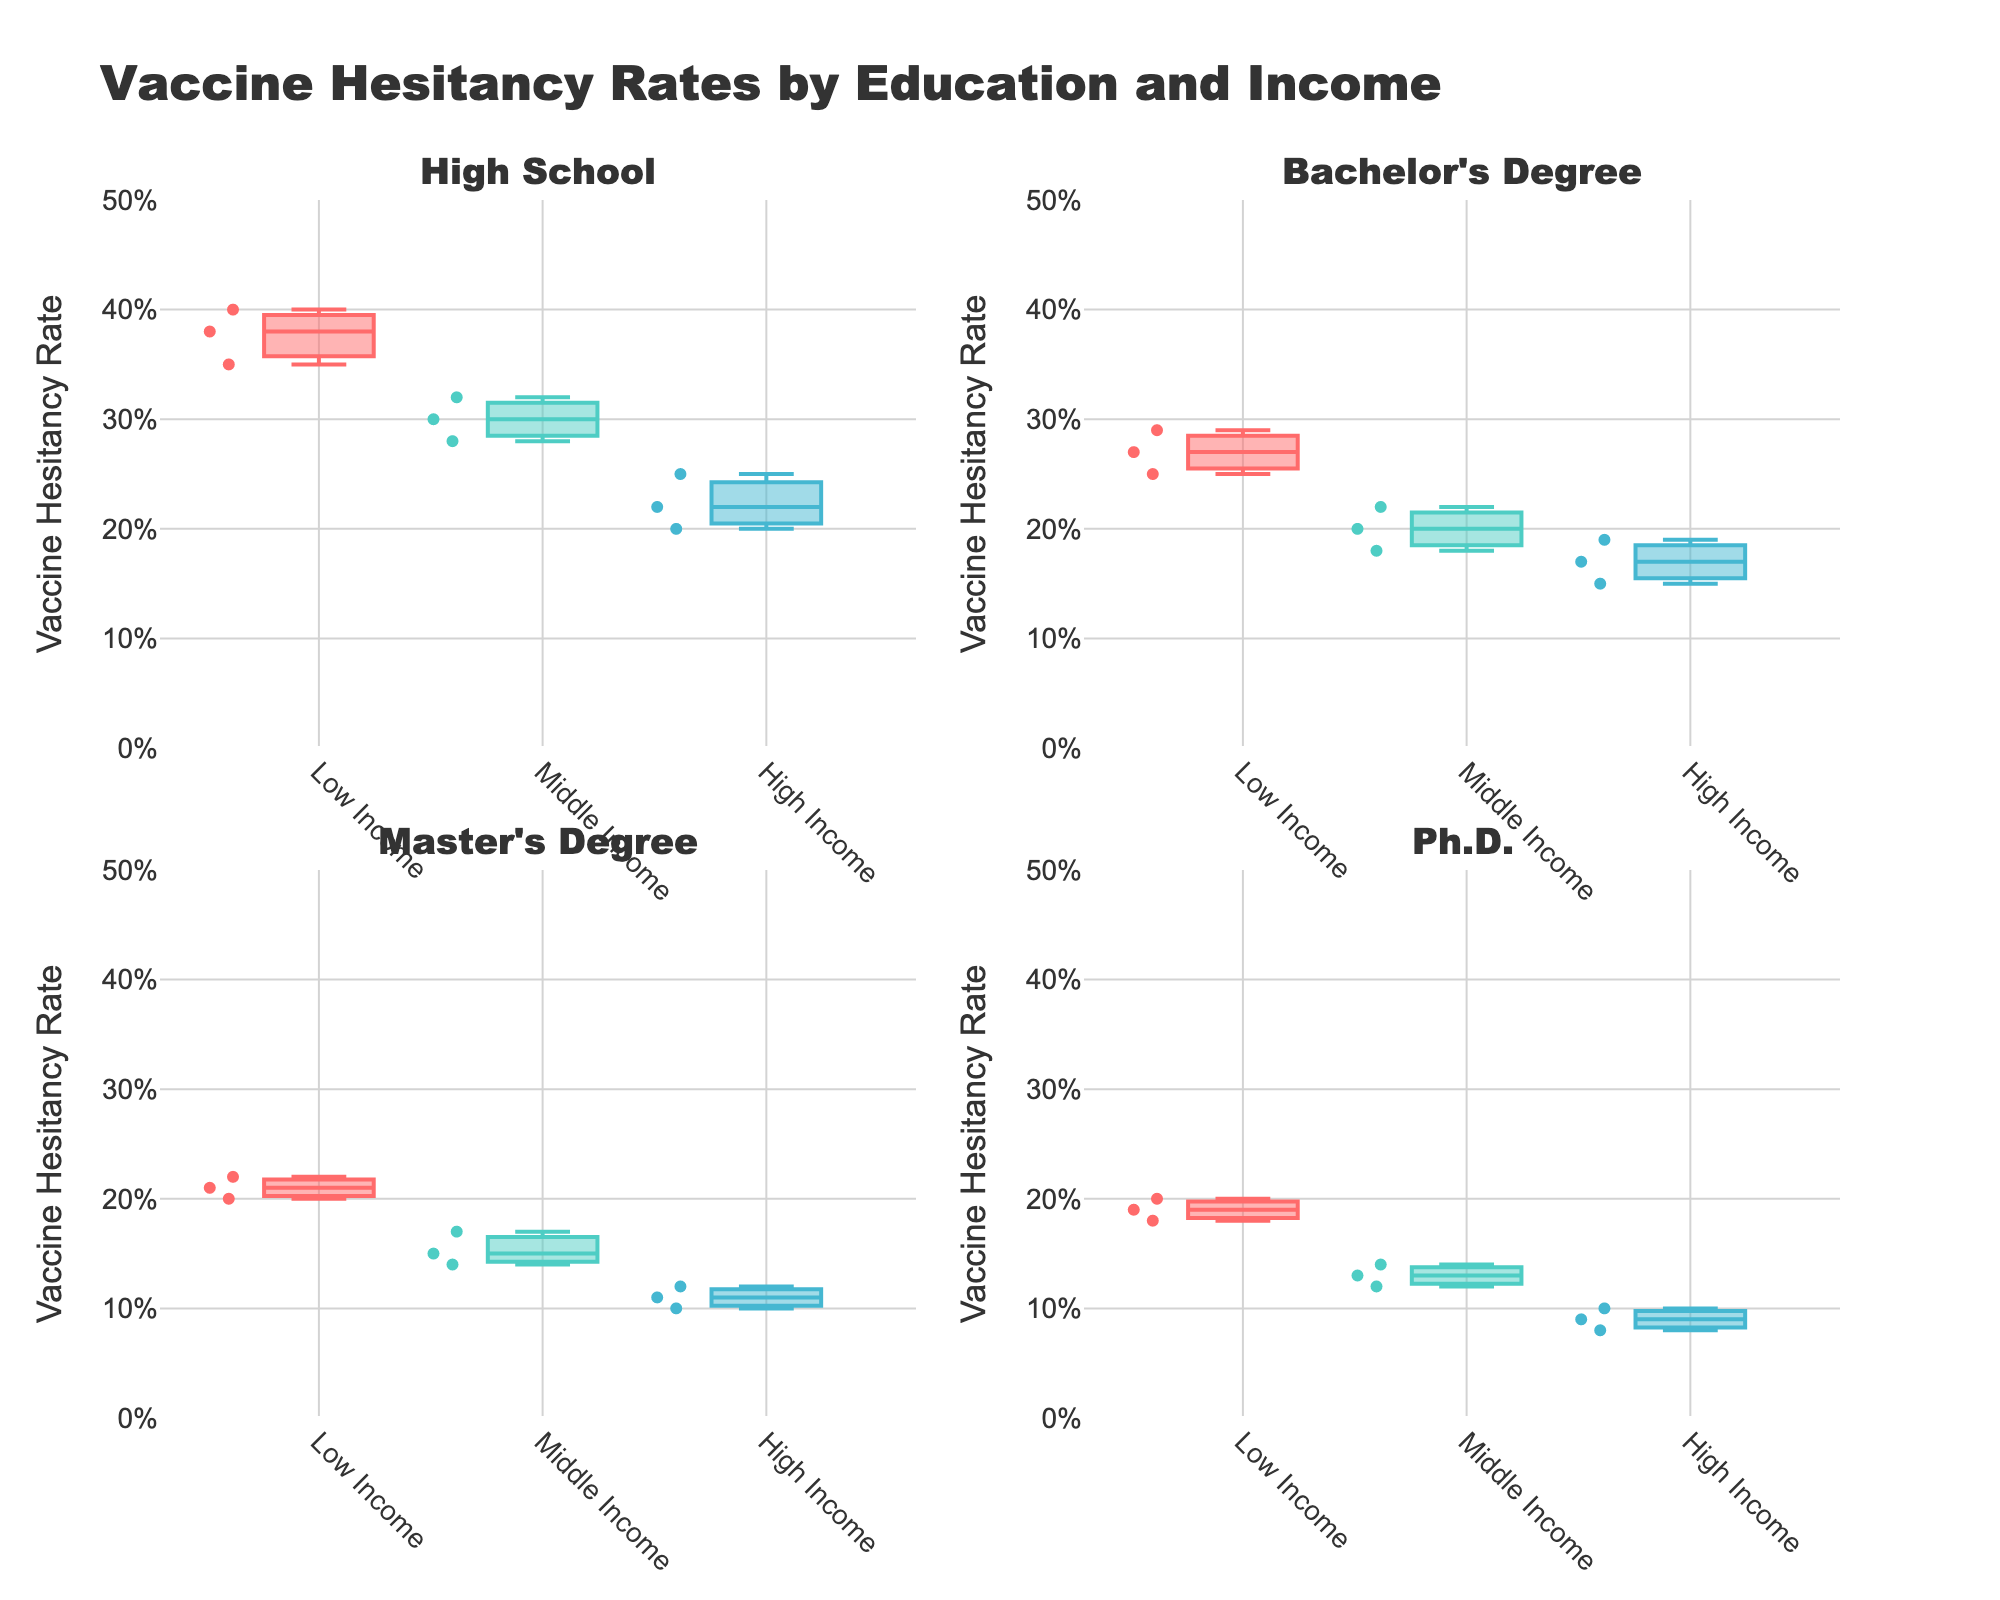how many box plots are shown in the entire figure? The plot has four subplots corresponding to different education levels (High School, Bachelor's Degree, Master's Degree, and Ph.D.). Each subplot contains three box plots corresponding to different income levels (Low, Middle, High), so the total is 4 subplots * 3 box plots each = 12 box plots in total.
Answer: 12 what's the title of the figure? The title text is displayed at the top-center of the plot. It reads "Vaccine Hesitancy Rates by Education and Income".
Answer: Vaccine Hesitancy Rates by Education and Income in which subplot do you find the highest hesitancy rate? To determine the highest hesitancy rate, look at each subplot. The highest boxplot whisker is in the High School subplot under Low Income, reaching about 40%.
Answer: High School - Low Income what's the median vaccine hesitancy rate for individuals with a Bachelor's Degree and High income? For the Bachelor's Degree - High Income box plot, identify the middle line in the box, which represents the median. It is around 0.17.
Answer: 0.17 compare the median vaccine hesitancy rates between High School and Master's Degree for Low Income. The median for High School - Low Income is around 35%, while for Master's Degree - Low Income, it is around 21%. 35% for High School is higher than 21% for Master's Degree.
Answer: High School is higher in which income group does the Ph.D. education level have the lowest vaccine hesitancy? The lowest median value for any of the box plots under the Ph.D. subplot is in the High-Income group, where the median is around 8%.
Answer: High Income compare the vaccine hesitancy rates for low-income earners with a Master's Degree and Ph.D. Which group shows less hesitancy on average? Inspect the box plots for Master's Degree - Low Income and Ph.D. - Low Income. Both show median rates around 21% (Master's Degree) and 19% (Ph.D.). Generally, the Ph.D. group displays slightly lower values.
Answer: Ph.D. shows less hesitancy which education level shows the most significant spread in vaccine hesitancy rates for middle-income earners? By comparing the length of the boxes and whiskers for middle-income earners across all education levels, the High School subplot shows the widest range from about 28% to 32%, the largest spread among all.
Answer: High School 